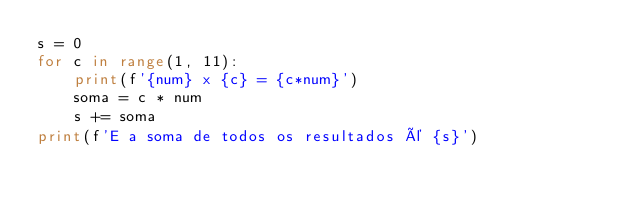<code> <loc_0><loc_0><loc_500><loc_500><_Python_>s = 0
for c in range(1, 11):
    print(f'{num} x {c} = {c*num}')
    soma = c * num
    s += soma
print(f'E a soma de todos os resultados é {s}')</code> 